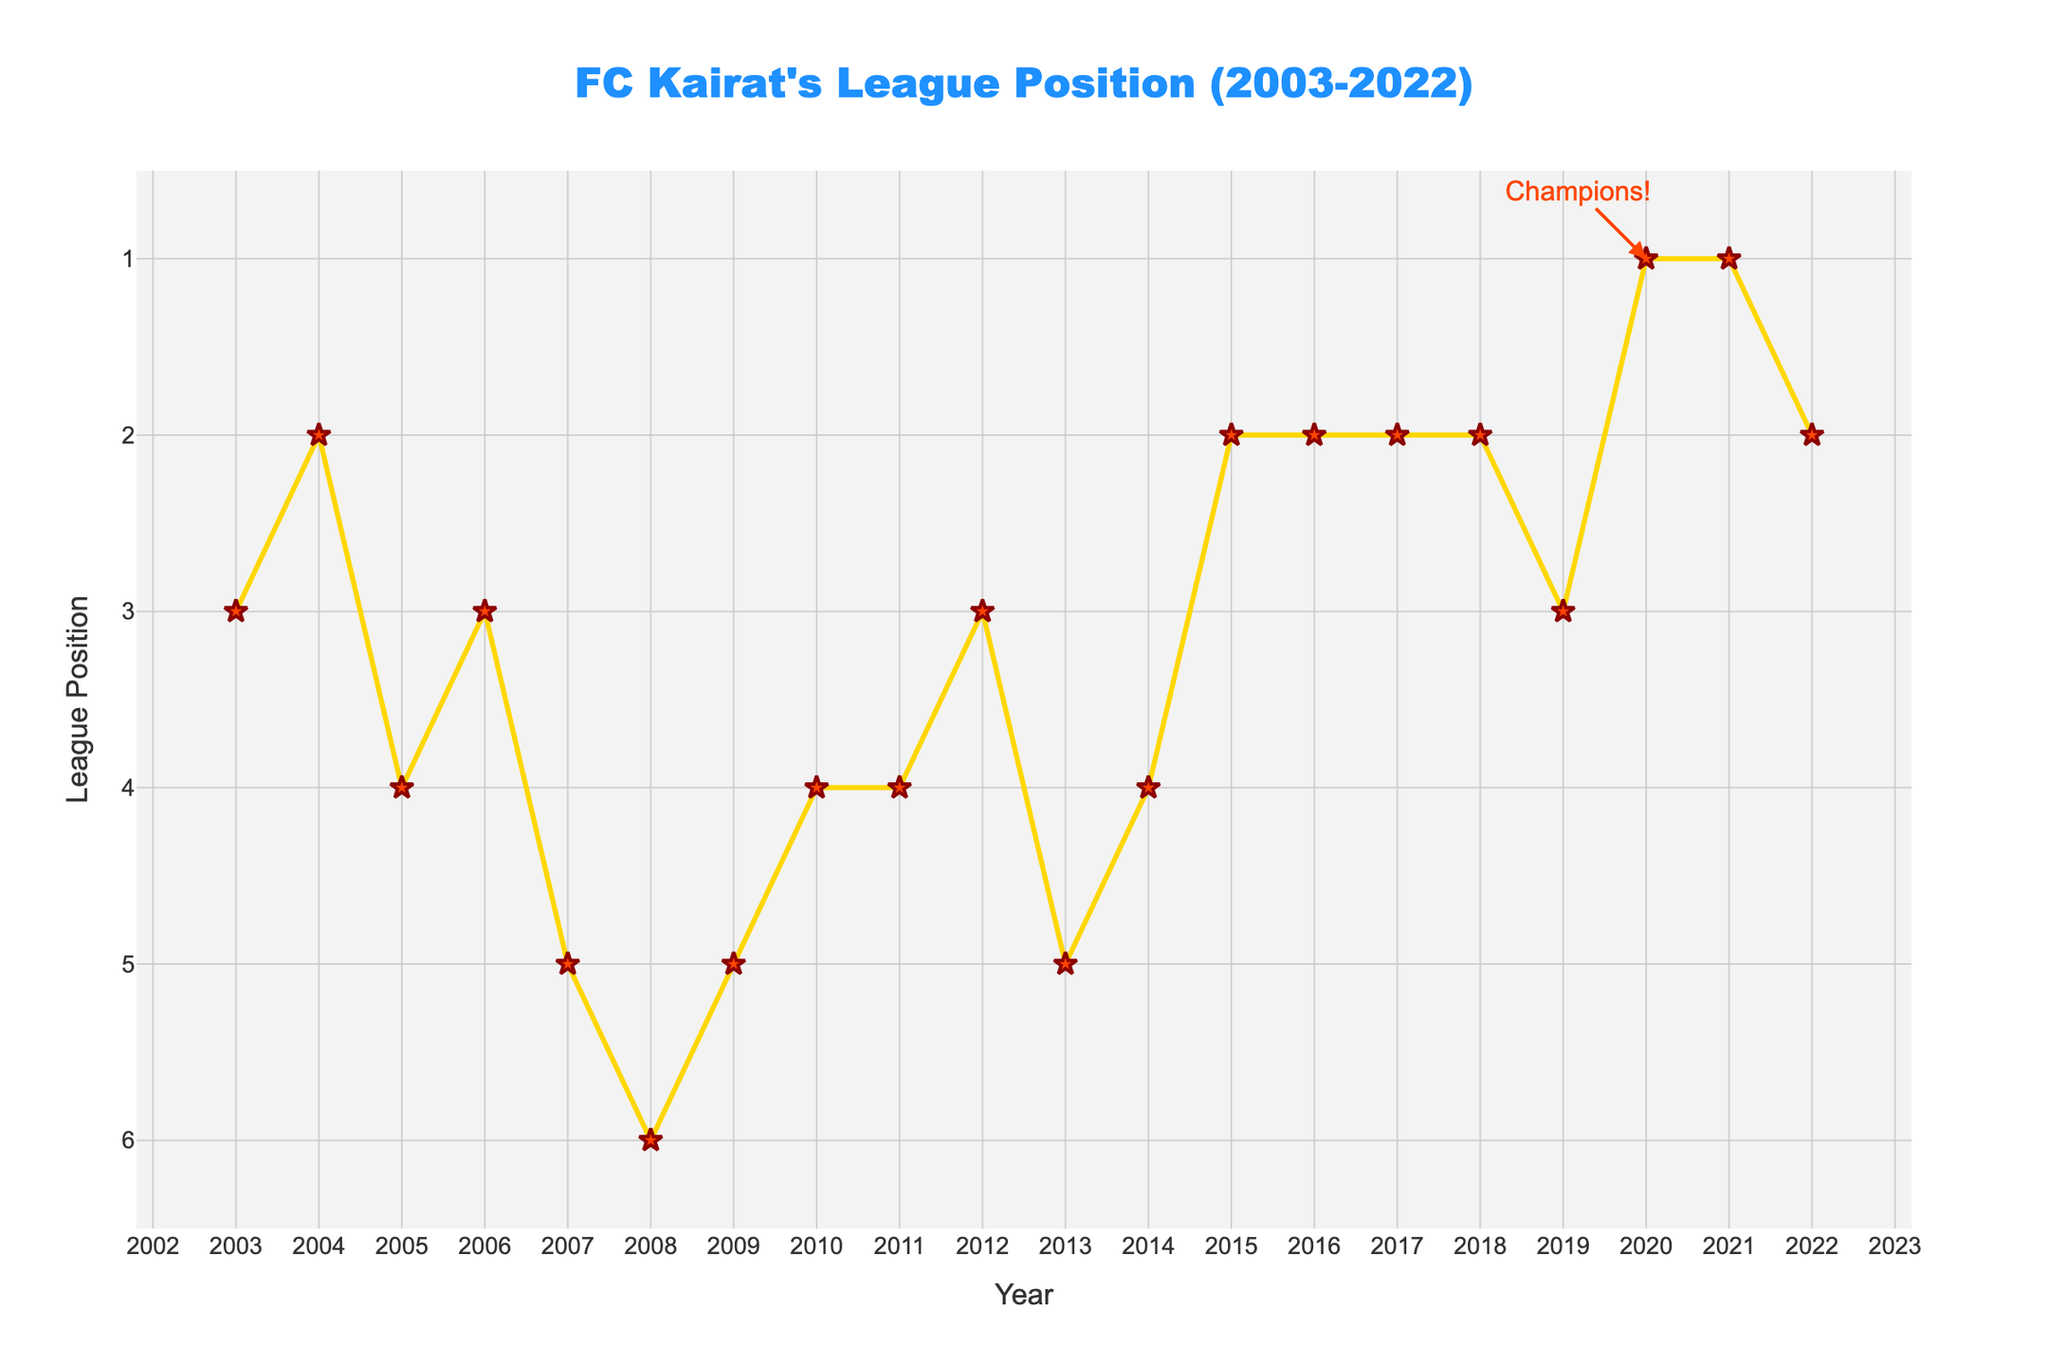Which year did FC Kairat achieve their highest league position? The highest league position is 1, which was achieved in 2020 and 2021.
Answer: 2020 and 2021 What is the median league position of FC Kairat from 2003 to 2022? To find the median, list the league positions in ascending order and find the middle number. Sorted positions: 1, 1, 2, 2, 2, 2, 2, 3, 3, 3, 3, 4, 4, 4, 4, 5, 5, 5, 6. The median is the 10th value in this list.
Answer: 3 How many times did FC Kairat finish in the top 3 positions from 2003 to 2022? Count the number of times the league position is 3 or better. Those years are 2003, 2004, 2006, 2012, 2015, 2016, 2017, 2018, 2019, 2020, 2021, 2022.
Answer: 12 In which year did FC Kairat have the biggest improvement in league position compared to the previous year? Calculate the difference in league position between each pair of consecutive years and identify the year with the largest positive difference. The biggest improvement is from position 3 in 2019 to position 1 in 2020.
Answer: 2020 When did FC Kairat experience the largest drop in league position compared to the previous year? Calculate the difference in league position between each pair of consecutive years and identify the year with the largest negative difference. The largest drop is from position 4 in 2005 to position 5 in 2006.
Answer: 2005 During which period did FC Kairat maintain the most consistent league position? Identify the longest consecutive years where the league position did not change. The most consistent period is from 2015 to 2018 when they finished 2nd each year.
Answer: 2015-2018 What is the average league position of FC Kairat over the 20 years? Sum all the league positions and divide by the number of years (20). The sum is 71, so the average position is 71/20 = 3.55.
Answer: 3.55 What annotations are highlighted on the plot? There is an annotation highlighted at year 2020 with the text "Champions!".
Answer: Champions! in 2020 Which year did FC Kairat reach the league position of 6? Look for the year corresponding to the league position of 6. This occurred in 2008.
Answer: 2008 